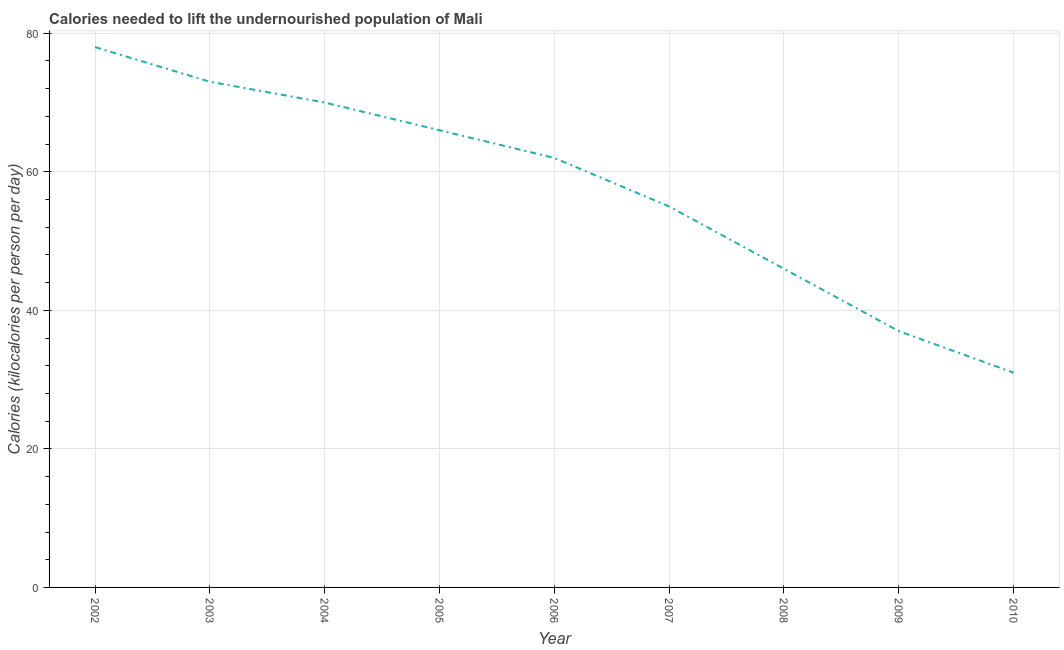What is the depth of food deficit in 2010?
Give a very brief answer. 31. Across all years, what is the maximum depth of food deficit?
Your answer should be compact. 78. Across all years, what is the minimum depth of food deficit?
Offer a terse response. 31. In which year was the depth of food deficit minimum?
Your answer should be compact. 2010. What is the sum of the depth of food deficit?
Offer a terse response. 518. What is the difference between the depth of food deficit in 2006 and 2009?
Keep it short and to the point. 25. What is the average depth of food deficit per year?
Ensure brevity in your answer.  57.56. What is the median depth of food deficit?
Give a very brief answer. 62. In how many years, is the depth of food deficit greater than 60 kilocalories?
Offer a very short reply. 5. Do a majority of the years between 2004 and 2003 (inclusive) have depth of food deficit greater than 12 kilocalories?
Make the answer very short. No. What is the ratio of the depth of food deficit in 2002 to that in 2009?
Your answer should be compact. 2.11. Is the depth of food deficit in 2004 less than that in 2009?
Your answer should be very brief. No. Is the sum of the depth of food deficit in 2003 and 2008 greater than the maximum depth of food deficit across all years?
Provide a short and direct response. Yes. What is the difference between the highest and the lowest depth of food deficit?
Your response must be concise. 47. In how many years, is the depth of food deficit greater than the average depth of food deficit taken over all years?
Make the answer very short. 5. How many lines are there?
Make the answer very short. 1. How many years are there in the graph?
Give a very brief answer. 9. Does the graph contain any zero values?
Provide a succinct answer. No. Does the graph contain grids?
Offer a very short reply. Yes. What is the title of the graph?
Keep it short and to the point. Calories needed to lift the undernourished population of Mali. What is the label or title of the Y-axis?
Give a very brief answer. Calories (kilocalories per person per day). What is the Calories (kilocalories per person per day) in 2002?
Provide a short and direct response. 78. What is the Calories (kilocalories per person per day) of 2003?
Give a very brief answer. 73. What is the Calories (kilocalories per person per day) of 2004?
Offer a very short reply. 70. What is the Calories (kilocalories per person per day) in 2005?
Offer a very short reply. 66. What is the Calories (kilocalories per person per day) of 2008?
Offer a very short reply. 46. What is the difference between the Calories (kilocalories per person per day) in 2002 and 2003?
Ensure brevity in your answer.  5. What is the difference between the Calories (kilocalories per person per day) in 2002 and 2006?
Your response must be concise. 16. What is the difference between the Calories (kilocalories per person per day) in 2002 and 2007?
Your answer should be compact. 23. What is the difference between the Calories (kilocalories per person per day) in 2003 and 2006?
Provide a succinct answer. 11. What is the difference between the Calories (kilocalories per person per day) in 2003 and 2007?
Your response must be concise. 18. What is the difference between the Calories (kilocalories per person per day) in 2003 and 2008?
Ensure brevity in your answer.  27. What is the difference between the Calories (kilocalories per person per day) in 2003 and 2009?
Your response must be concise. 36. What is the difference between the Calories (kilocalories per person per day) in 2004 and 2005?
Ensure brevity in your answer.  4. What is the difference between the Calories (kilocalories per person per day) in 2004 and 2007?
Offer a very short reply. 15. What is the difference between the Calories (kilocalories per person per day) in 2004 and 2008?
Provide a short and direct response. 24. What is the difference between the Calories (kilocalories per person per day) in 2004 and 2009?
Give a very brief answer. 33. What is the difference between the Calories (kilocalories per person per day) in 2004 and 2010?
Make the answer very short. 39. What is the difference between the Calories (kilocalories per person per day) in 2005 and 2007?
Ensure brevity in your answer.  11. What is the difference between the Calories (kilocalories per person per day) in 2005 and 2008?
Your answer should be compact. 20. What is the difference between the Calories (kilocalories per person per day) in 2005 and 2009?
Provide a succinct answer. 29. What is the difference between the Calories (kilocalories per person per day) in 2006 and 2007?
Your answer should be compact. 7. What is the difference between the Calories (kilocalories per person per day) in 2006 and 2010?
Your response must be concise. 31. What is the difference between the Calories (kilocalories per person per day) in 2007 and 2010?
Offer a very short reply. 24. What is the difference between the Calories (kilocalories per person per day) in 2008 and 2009?
Provide a succinct answer. 9. What is the difference between the Calories (kilocalories per person per day) in 2009 and 2010?
Give a very brief answer. 6. What is the ratio of the Calories (kilocalories per person per day) in 2002 to that in 2003?
Give a very brief answer. 1.07. What is the ratio of the Calories (kilocalories per person per day) in 2002 to that in 2004?
Your answer should be compact. 1.11. What is the ratio of the Calories (kilocalories per person per day) in 2002 to that in 2005?
Provide a short and direct response. 1.18. What is the ratio of the Calories (kilocalories per person per day) in 2002 to that in 2006?
Provide a succinct answer. 1.26. What is the ratio of the Calories (kilocalories per person per day) in 2002 to that in 2007?
Provide a succinct answer. 1.42. What is the ratio of the Calories (kilocalories per person per day) in 2002 to that in 2008?
Your response must be concise. 1.7. What is the ratio of the Calories (kilocalories per person per day) in 2002 to that in 2009?
Ensure brevity in your answer.  2.11. What is the ratio of the Calories (kilocalories per person per day) in 2002 to that in 2010?
Offer a terse response. 2.52. What is the ratio of the Calories (kilocalories per person per day) in 2003 to that in 2004?
Ensure brevity in your answer.  1.04. What is the ratio of the Calories (kilocalories per person per day) in 2003 to that in 2005?
Your answer should be compact. 1.11. What is the ratio of the Calories (kilocalories per person per day) in 2003 to that in 2006?
Provide a succinct answer. 1.18. What is the ratio of the Calories (kilocalories per person per day) in 2003 to that in 2007?
Provide a succinct answer. 1.33. What is the ratio of the Calories (kilocalories per person per day) in 2003 to that in 2008?
Offer a very short reply. 1.59. What is the ratio of the Calories (kilocalories per person per day) in 2003 to that in 2009?
Your response must be concise. 1.97. What is the ratio of the Calories (kilocalories per person per day) in 2003 to that in 2010?
Keep it short and to the point. 2.35. What is the ratio of the Calories (kilocalories per person per day) in 2004 to that in 2005?
Offer a terse response. 1.06. What is the ratio of the Calories (kilocalories per person per day) in 2004 to that in 2006?
Ensure brevity in your answer.  1.13. What is the ratio of the Calories (kilocalories per person per day) in 2004 to that in 2007?
Your answer should be very brief. 1.27. What is the ratio of the Calories (kilocalories per person per day) in 2004 to that in 2008?
Your response must be concise. 1.52. What is the ratio of the Calories (kilocalories per person per day) in 2004 to that in 2009?
Make the answer very short. 1.89. What is the ratio of the Calories (kilocalories per person per day) in 2004 to that in 2010?
Keep it short and to the point. 2.26. What is the ratio of the Calories (kilocalories per person per day) in 2005 to that in 2006?
Provide a short and direct response. 1.06. What is the ratio of the Calories (kilocalories per person per day) in 2005 to that in 2008?
Offer a very short reply. 1.44. What is the ratio of the Calories (kilocalories per person per day) in 2005 to that in 2009?
Provide a succinct answer. 1.78. What is the ratio of the Calories (kilocalories per person per day) in 2005 to that in 2010?
Provide a short and direct response. 2.13. What is the ratio of the Calories (kilocalories per person per day) in 2006 to that in 2007?
Your answer should be very brief. 1.13. What is the ratio of the Calories (kilocalories per person per day) in 2006 to that in 2008?
Offer a very short reply. 1.35. What is the ratio of the Calories (kilocalories per person per day) in 2006 to that in 2009?
Your answer should be very brief. 1.68. What is the ratio of the Calories (kilocalories per person per day) in 2006 to that in 2010?
Give a very brief answer. 2. What is the ratio of the Calories (kilocalories per person per day) in 2007 to that in 2008?
Keep it short and to the point. 1.2. What is the ratio of the Calories (kilocalories per person per day) in 2007 to that in 2009?
Ensure brevity in your answer.  1.49. What is the ratio of the Calories (kilocalories per person per day) in 2007 to that in 2010?
Your answer should be very brief. 1.77. What is the ratio of the Calories (kilocalories per person per day) in 2008 to that in 2009?
Keep it short and to the point. 1.24. What is the ratio of the Calories (kilocalories per person per day) in 2008 to that in 2010?
Offer a very short reply. 1.48. What is the ratio of the Calories (kilocalories per person per day) in 2009 to that in 2010?
Your answer should be compact. 1.19. 